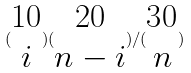Convert formula to latex. <formula><loc_0><loc_0><loc_500><loc_500>( \begin{matrix} 1 0 \\ i \end{matrix} ) ( \begin{matrix} 2 0 \\ n - i \end{matrix} ) / ( \begin{matrix} 3 0 \\ n \end{matrix} )</formula> 